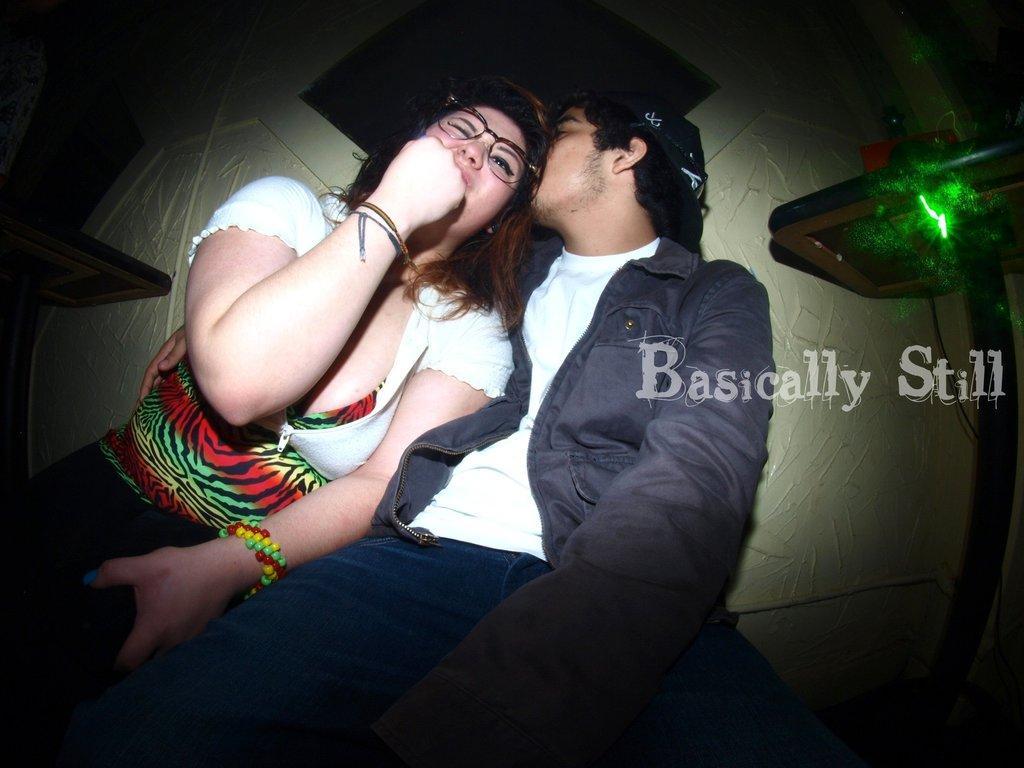In one or two sentences, can you explain what this image depicts? In this picture we can see a man and a woman wore a spectacle and in the background we can see the wall. 